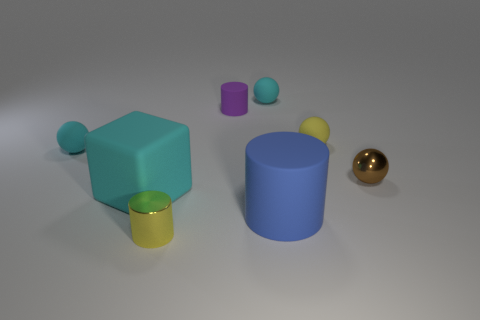Subtract all small cylinders. How many cylinders are left? 1 Subtract all red cylinders. How many cyan spheres are left? 2 Subtract 1 cylinders. How many cylinders are left? 2 Subtract all yellow balls. How many balls are left? 3 Add 2 tiny red cubes. How many objects exist? 10 Subtract all blue spheres. Subtract all red cylinders. How many spheres are left? 4 Subtract all blocks. How many objects are left? 7 Add 4 yellow things. How many yellow things exist? 6 Subtract 1 purple cylinders. How many objects are left? 7 Subtract all small shiny things. Subtract all tiny cyan shiny cubes. How many objects are left? 6 